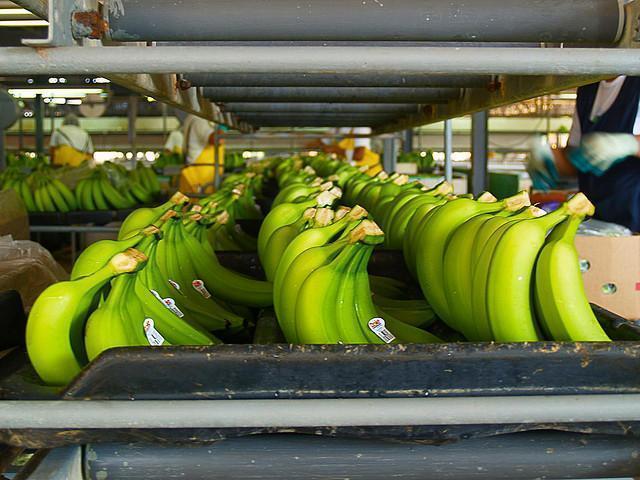Which food company produces these bananas?
From the following set of four choices, select the accurate answer to respond to the question.
Options: Dole, bayer, coca-cola, chiquita. Dole. 